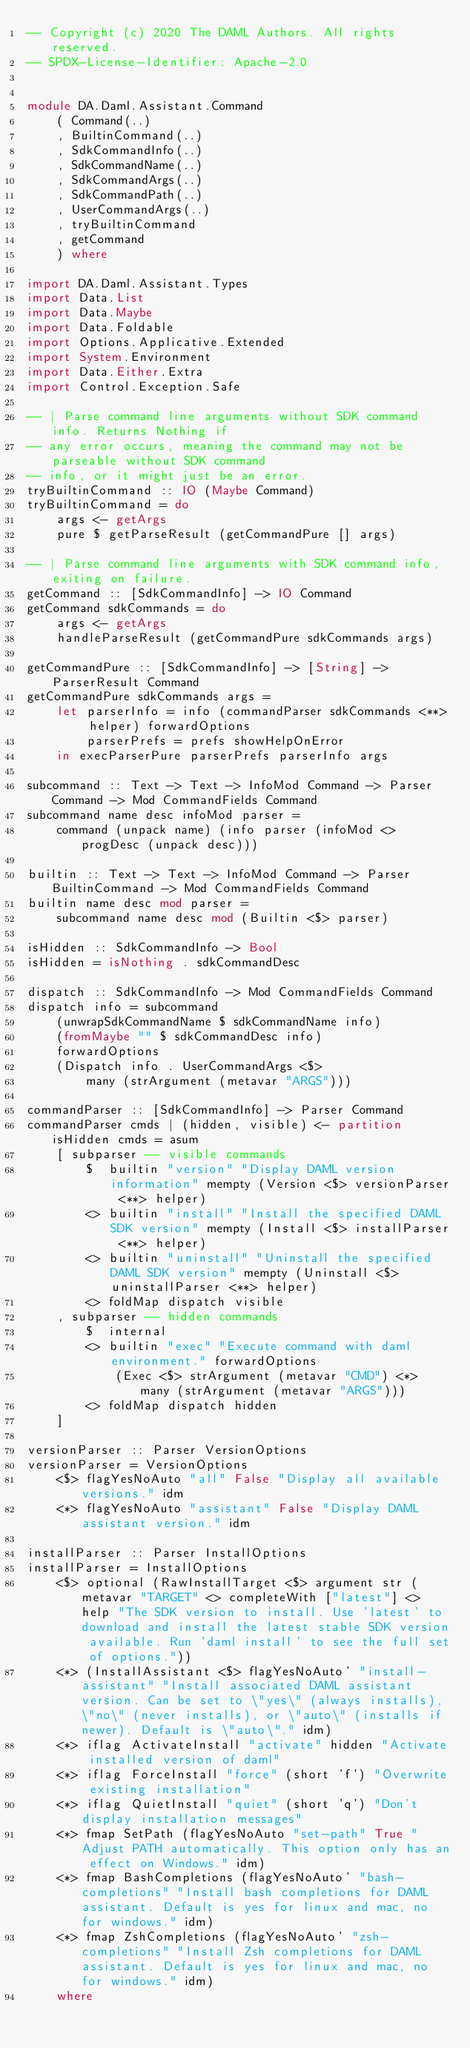Convert code to text. <code><loc_0><loc_0><loc_500><loc_500><_Haskell_>-- Copyright (c) 2020 The DAML Authors. All rights reserved.
-- SPDX-License-Identifier: Apache-2.0


module DA.Daml.Assistant.Command
    ( Command(..)
    , BuiltinCommand(..)
    , SdkCommandInfo(..)
    , SdkCommandName(..)
    , SdkCommandArgs(..)
    , SdkCommandPath(..)
    , UserCommandArgs(..)
    , tryBuiltinCommand
    , getCommand
    ) where

import DA.Daml.Assistant.Types
import Data.List
import Data.Maybe
import Data.Foldable
import Options.Applicative.Extended
import System.Environment
import Data.Either.Extra
import Control.Exception.Safe

-- | Parse command line arguments without SDK command info. Returns Nothing if
-- any error occurs, meaning the command may not be parseable without SDK command
-- info, or it might just be an error.
tryBuiltinCommand :: IO (Maybe Command)
tryBuiltinCommand = do
    args <- getArgs
    pure $ getParseResult (getCommandPure [] args)

-- | Parse command line arguments with SDK command info, exiting on failure.
getCommand :: [SdkCommandInfo] -> IO Command
getCommand sdkCommands = do
    args <- getArgs
    handleParseResult (getCommandPure sdkCommands args)

getCommandPure :: [SdkCommandInfo] -> [String] -> ParserResult Command
getCommandPure sdkCommands args =
    let parserInfo = info (commandParser sdkCommands <**> helper) forwardOptions
        parserPrefs = prefs showHelpOnError
    in execParserPure parserPrefs parserInfo args

subcommand :: Text -> Text -> InfoMod Command -> Parser Command -> Mod CommandFields Command
subcommand name desc infoMod parser =
    command (unpack name) (info parser (infoMod <> progDesc (unpack desc)))

builtin :: Text -> Text -> InfoMod Command -> Parser BuiltinCommand -> Mod CommandFields Command
builtin name desc mod parser =
    subcommand name desc mod (Builtin <$> parser)

isHidden :: SdkCommandInfo -> Bool
isHidden = isNothing . sdkCommandDesc

dispatch :: SdkCommandInfo -> Mod CommandFields Command
dispatch info = subcommand
    (unwrapSdkCommandName $ sdkCommandName info)
    (fromMaybe "" $ sdkCommandDesc info)
    forwardOptions
    (Dispatch info . UserCommandArgs <$>
        many (strArgument (metavar "ARGS")))

commandParser :: [SdkCommandInfo] -> Parser Command
commandParser cmds | (hidden, visible) <- partition isHidden cmds = asum
    [ subparser -- visible commands
        $  builtin "version" "Display DAML version information" mempty (Version <$> versionParser <**> helper)
        <> builtin "install" "Install the specified DAML SDK version" mempty (Install <$> installParser <**> helper)
        <> builtin "uninstall" "Uninstall the specified DAML SDK version" mempty (Uninstall <$> uninstallParser <**> helper)
        <> foldMap dispatch visible
    , subparser -- hidden commands
        $  internal
        <> builtin "exec" "Execute command with daml environment." forwardOptions
            (Exec <$> strArgument (metavar "CMD") <*> many (strArgument (metavar "ARGS")))
        <> foldMap dispatch hidden
    ]

versionParser :: Parser VersionOptions
versionParser = VersionOptions
    <$> flagYesNoAuto "all" False "Display all available versions." idm
    <*> flagYesNoAuto "assistant" False "Display DAML assistant version." idm

installParser :: Parser InstallOptions
installParser = InstallOptions
    <$> optional (RawInstallTarget <$> argument str (metavar "TARGET" <> completeWith ["latest"] <> help "The SDK version to install. Use 'latest' to download and install the latest stable SDK version available. Run 'daml install' to see the full set of options."))
    <*> (InstallAssistant <$> flagYesNoAuto' "install-assistant" "Install associated DAML assistant version. Can be set to \"yes\" (always installs), \"no\" (never installs), or \"auto\" (installs if newer). Default is \"auto\"." idm)
    <*> iflag ActivateInstall "activate" hidden "Activate installed version of daml"
    <*> iflag ForceInstall "force" (short 'f') "Overwrite existing installation"
    <*> iflag QuietInstall "quiet" (short 'q') "Don't display installation messages"
    <*> fmap SetPath (flagYesNoAuto "set-path" True "Adjust PATH automatically. This option only has an effect on Windows." idm)
    <*> fmap BashCompletions (flagYesNoAuto' "bash-completions" "Install bash completions for DAML assistant. Default is yes for linux and mac, no for windows." idm)
    <*> fmap ZshCompletions (flagYesNoAuto' "zsh-completions" "Install Zsh completions for DAML assistant. Default is yes for linux and mac, no for windows." idm)
    where</code> 